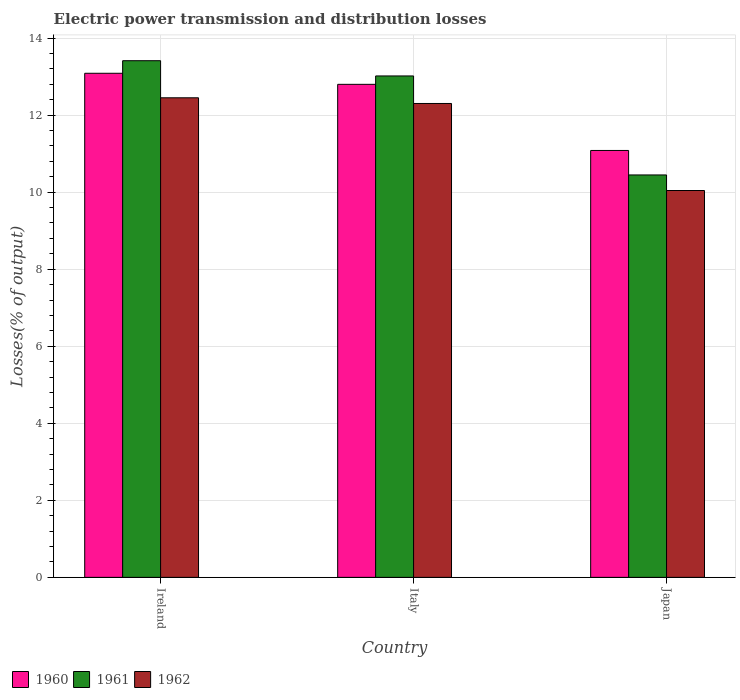How many groups of bars are there?
Your answer should be compact. 3. Are the number of bars per tick equal to the number of legend labels?
Give a very brief answer. Yes. What is the label of the 1st group of bars from the left?
Provide a succinct answer. Ireland. What is the electric power transmission and distribution losses in 1960 in Italy?
Offer a terse response. 12.8. Across all countries, what is the maximum electric power transmission and distribution losses in 1960?
Make the answer very short. 13.09. Across all countries, what is the minimum electric power transmission and distribution losses in 1961?
Make the answer very short. 10.45. In which country was the electric power transmission and distribution losses in 1960 maximum?
Ensure brevity in your answer.  Ireland. In which country was the electric power transmission and distribution losses in 1962 minimum?
Give a very brief answer. Japan. What is the total electric power transmission and distribution losses in 1960 in the graph?
Provide a succinct answer. 36.97. What is the difference between the electric power transmission and distribution losses in 1962 in Ireland and that in Japan?
Your answer should be very brief. 2.41. What is the difference between the electric power transmission and distribution losses in 1961 in Italy and the electric power transmission and distribution losses in 1962 in Japan?
Offer a very short reply. 2.97. What is the average electric power transmission and distribution losses in 1962 per country?
Ensure brevity in your answer.  11.6. What is the difference between the electric power transmission and distribution losses of/in 1961 and electric power transmission and distribution losses of/in 1960 in Ireland?
Keep it short and to the point. 0.33. What is the ratio of the electric power transmission and distribution losses in 1961 in Ireland to that in Italy?
Offer a very short reply. 1.03. Is the difference between the electric power transmission and distribution losses in 1961 in Ireland and Italy greater than the difference between the electric power transmission and distribution losses in 1960 in Ireland and Italy?
Make the answer very short. Yes. What is the difference between the highest and the second highest electric power transmission and distribution losses in 1961?
Give a very brief answer. 2.57. What is the difference between the highest and the lowest electric power transmission and distribution losses in 1962?
Make the answer very short. 2.41. In how many countries, is the electric power transmission and distribution losses in 1962 greater than the average electric power transmission and distribution losses in 1962 taken over all countries?
Provide a short and direct response. 2. Is the sum of the electric power transmission and distribution losses in 1962 in Italy and Japan greater than the maximum electric power transmission and distribution losses in 1961 across all countries?
Your answer should be very brief. Yes. Are the values on the major ticks of Y-axis written in scientific E-notation?
Your answer should be compact. No. Does the graph contain any zero values?
Offer a very short reply. No. Does the graph contain grids?
Provide a succinct answer. Yes. Where does the legend appear in the graph?
Provide a short and direct response. Bottom left. How many legend labels are there?
Your answer should be very brief. 3. How are the legend labels stacked?
Keep it short and to the point. Horizontal. What is the title of the graph?
Give a very brief answer. Electric power transmission and distribution losses. What is the label or title of the Y-axis?
Your response must be concise. Losses(% of output). What is the Losses(% of output) of 1960 in Ireland?
Give a very brief answer. 13.09. What is the Losses(% of output) of 1961 in Ireland?
Your answer should be very brief. 13.41. What is the Losses(% of output) of 1962 in Ireland?
Your answer should be very brief. 12.45. What is the Losses(% of output) of 1960 in Italy?
Your answer should be very brief. 12.8. What is the Losses(% of output) in 1961 in Italy?
Offer a very short reply. 13.02. What is the Losses(% of output) in 1962 in Italy?
Give a very brief answer. 12.3. What is the Losses(% of output) in 1960 in Japan?
Provide a short and direct response. 11.08. What is the Losses(% of output) in 1961 in Japan?
Keep it short and to the point. 10.45. What is the Losses(% of output) of 1962 in Japan?
Your response must be concise. 10.04. Across all countries, what is the maximum Losses(% of output) of 1960?
Offer a terse response. 13.09. Across all countries, what is the maximum Losses(% of output) in 1961?
Your answer should be compact. 13.41. Across all countries, what is the maximum Losses(% of output) in 1962?
Your response must be concise. 12.45. Across all countries, what is the minimum Losses(% of output) in 1960?
Provide a short and direct response. 11.08. Across all countries, what is the minimum Losses(% of output) in 1961?
Provide a short and direct response. 10.45. Across all countries, what is the minimum Losses(% of output) in 1962?
Your response must be concise. 10.04. What is the total Losses(% of output) in 1960 in the graph?
Keep it short and to the point. 36.97. What is the total Losses(% of output) of 1961 in the graph?
Offer a terse response. 36.88. What is the total Losses(% of output) of 1962 in the graph?
Ensure brevity in your answer.  34.79. What is the difference between the Losses(% of output) in 1960 in Ireland and that in Italy?
Give a very brief answer. 0.29. What is the difference between the Losses(% of output) of 1961 in Ireland and that in Italy?
Your answer should be compact. 0.4. What is the difference between the Losses(% of output) in 1962 in Ireland and that in Italy?
Give a very brief answer. 0.15. What is the difference between the Losses(% of output) of 1960 in Ireland and that in Japan?
Keep it short and to the point. 2. What is the difference between the Losses(% of output) in 1961 in Ireland and that in Japan?
Provide a short and direct response. 2.97. What is the difference between the Losses(% of output) of 1962 in Ireland and that in Japan?
Give a very brief answer. 2.41. What is the difference between the Losses(% of output) in 1960 in Italy and that in Japan?
Make the answer very short. 1.72. What is the difference between the Losses(% of output) of 1961 in Italy and that in Japan?
Give a very brief answer. 2.57. What is the difference between the Losses(% of output) of 1962 in Italy and that in Japan?
Your response must be concise. 2.26. What is the difference between the Losses(% of output) in 1960 in Ireland and the Losses(% of output) in 1961 in Italy?
Ensure brevity in your answer.  0.07. What is the difference between the Losses(% of output) in 1960 in Ireland and the Losses(% of output) in 1962 in Italy?
Provide a succinct answer. 0.78. What is the difference between the Losses(% of output) in 1961 in Ireland and the Losses(% of output) in 1962 in Italy?
Provide a short and direct response. 1.11. What is the difference between the Losses(% of output) in 1960 in Ireland and the Losses(% of output) in 1961 in Japan?
Your answer should be very brief. 2.64. What is the difference between the Losses(% of output) in 1960 in Ireland and the Losses(% of output) in 1962 in Japan?
Your answer should be very brief. 3.04. What is the difference between the Losses(% of output) of 1961 in Ireland and the Losses(% of output) of 1962 in Japan?
Give a very brief answer. 3.37. What is the difference between the Losses(% of output) of 1960 in Italy and the Losses(% of output) of 1961 in Japan?
Ensure brevity in your answer.  2.35. What is the difference between the Losses(% of output) of 1960 in Italy and the Losses(% of output) of 1962 in Japan?
Provide a succinct answer. 2.76. What is the difference between the Losses(% of output) in 1961 in Italy and the Losses(% of output) in 1962 in Japan?
Offer a terse response. 2.97. What is the average Losses(% of output) in 1960 per country?
Offer a very short reply. 12.32. What is the average Losses(% of output) in 1961 per country?
Provide a short and direct response. 12.29. What is the average Losses(% of output) in 1962 per country?
Offer a very short reply. 11.6. What is the difference between the Losses(% of output) in 1960 and Losses(% of output) in 1961 in Ireland?
Keep it short and to the point. -0.33. What is the difference between the Losses(% of output) in 1960 and Losses(% of output) in 1962 in Ireland?
Provide a succinct answer. 0.64. What is the difference between the Losses(% of output) in 1961 and Losses(% of output) in 1962 in Ireland?
Your answer should be very brief. 0.96. What is the difference between the Losses(% of output) in 1960 and Losses(% of output) in 1961 in Italy?
Keep it short and to the point. -0.22. What is the difference between the Losses(% of output) of 1960 and Losses(% of output) of 1962 in Italy?
Your answer should be compact. 0.5. What is the difference between the Losses(% of output) of 1961 and Losses(% of output) of 1962 in Italy?
Your answer should be very brief. 0.71. What is the difference between the Losses(% of output) in 1960 and Losses(% of output) in 1961 in Japan?
Keep it short and to the point. 0.64. What is the difference between the Losses(% of output) of 1960 and Losses(% of output) of 1962 in Japan?
Give a very brief answer. 1.04. What is the difference between the Losses(% of output) of 1961 and Losses(% of output) of 1962 in Japan?
Offer a very short reply. 0.4. What is the ratio of the Losses(% of output) of 1960 in Ireland to that in Italy?
Your answer should be very brief. 1.02. What is the ratio of the Losses(% of output) of 1961 in Ireland to that in Italy?
Your answer should be very brief. 1.03. What is the ratio of the Losses(% of output) in 1962 in Ireland to that in Italy?
Your answer should be compact. 1.01. What is the ratio of the Losses(% of output) in 1960 in Ireland to that in Japan?
Your response must be concise. 1.18. What is the ratio of the Losses(% of output) of 1961 in Ireland to that in Japan?
Make the answer very short. 1.28. What is the ratio of the Losses(% of output) of 1962 in Ireland to that in Japan?
Your response must be concise. 1.24. What is the ratio of the Losses(% of output) in 1960 in Italy to that in Japan?
Offer a terse response. 1.15. What is the ratio of the Losses(% of output) of 1961 in Italy to that in Japan?
Ensure brevity in your answer.  1.25. What is the ratio of the Losses(% of output) of 1962 in Italy to that in Japan?
Ensure brevity in your answer.  1.23. What is the difference between the highest and the second highest Losses(% of output) in 1960?
Ensure brevity in your answer.  0.29. What is the difference between the highest and the second highest Losses(% of output) in 1961?
Make the answer very short. 0.4. What is the difference between the highest and the second highest Losses(% of output) of 1962?
Your response must be concise. 0.15. What is the difference between the highest and the lowest Losses(% of output) of 1960?
Keep it short and to the point. 2. What is the difference between the highest and the lowest Losses(% of output) in 1961?
Offer a terse response. 2.97. What is the difference between the highest and the lowest Losses(% of output) of 1962?
Your answer should be very brief. 2.41. 